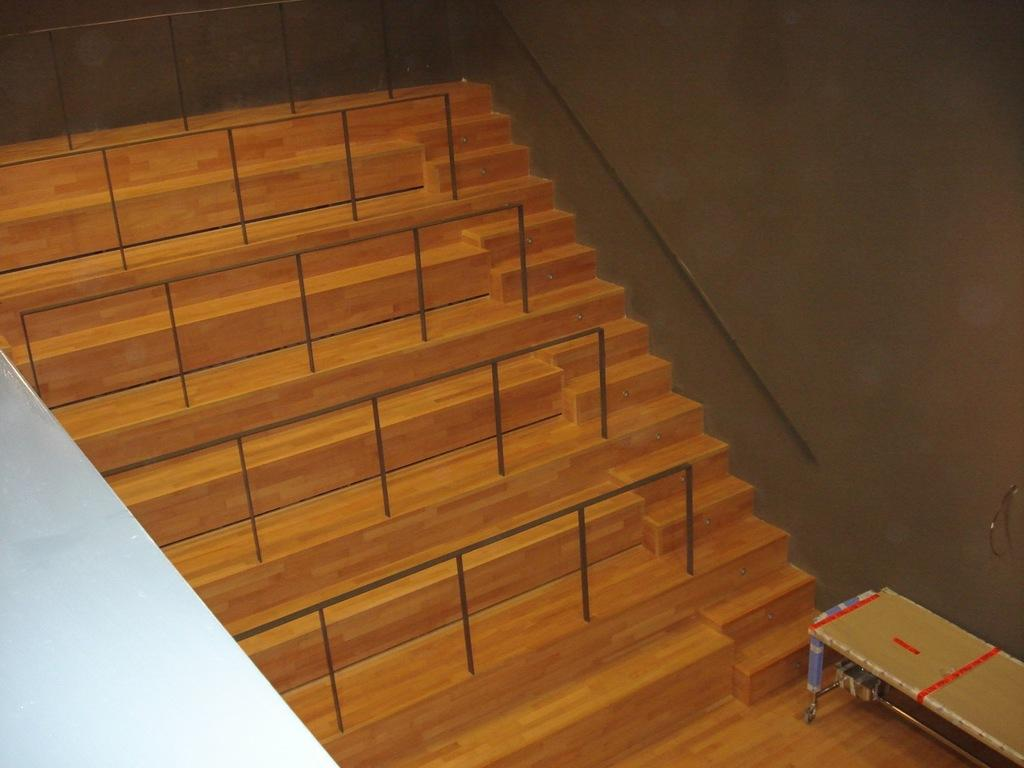What type of architectural feature is present in the image? There are steps in the image. What else can be seen in the image besides the steps? There is fencing and a table in the image. Where is the table located in the image? The table is in the bottom right side of the image. What is visible at the top of the image? There is a wall at the top of the image. What type of range can be seen in the image? There is no range present in the image. What selection of items is available on the table in the image? The image does not provide information about the items on the table, so we cannot determine the selection. 